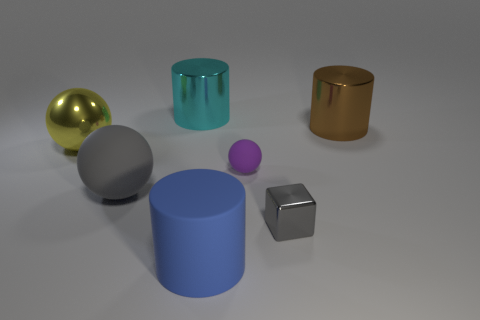Is the sphere in front of the small matte object made of the same material as the large sphere behind the large gray rubber thing?
Ensure brevity in your answer.  No. Is the number of blue objects behind the big cyan object less than the number of large metal blocks?
Keep it short and to the point. No. Is there anything else that has the same shape as the gray shiny object?
Your response must be concise. No. What color is the other big shiny object that is the same shape as the large cyan metallic thing?
Your answer should be very brief. Brown. There is a cylinder that is in front of the yellow object; does it have the same size as the tiny metal thing?
Ensure brevity in your answer.  No. There is a sphere right of the gray object that is on the left side of the small gray cube; how big is it?
Give a very brief answer. Small. Is the material of the large blue thing the same as the large ball behind the purple ball?
Your answer should be very brief. No. Is the number of metal things behind the small sphere less than the number of gray matte spheres left of the yellow object?
Your answer should be very brief. No. There is a sphere that is the same material as the small gray block; what color is it?
Your response must be concise. Yellow. There is a tiny thing that is on the left side of the small metal block; is there a shiny cylinder right of it?
Make the answer very short. Yes. 